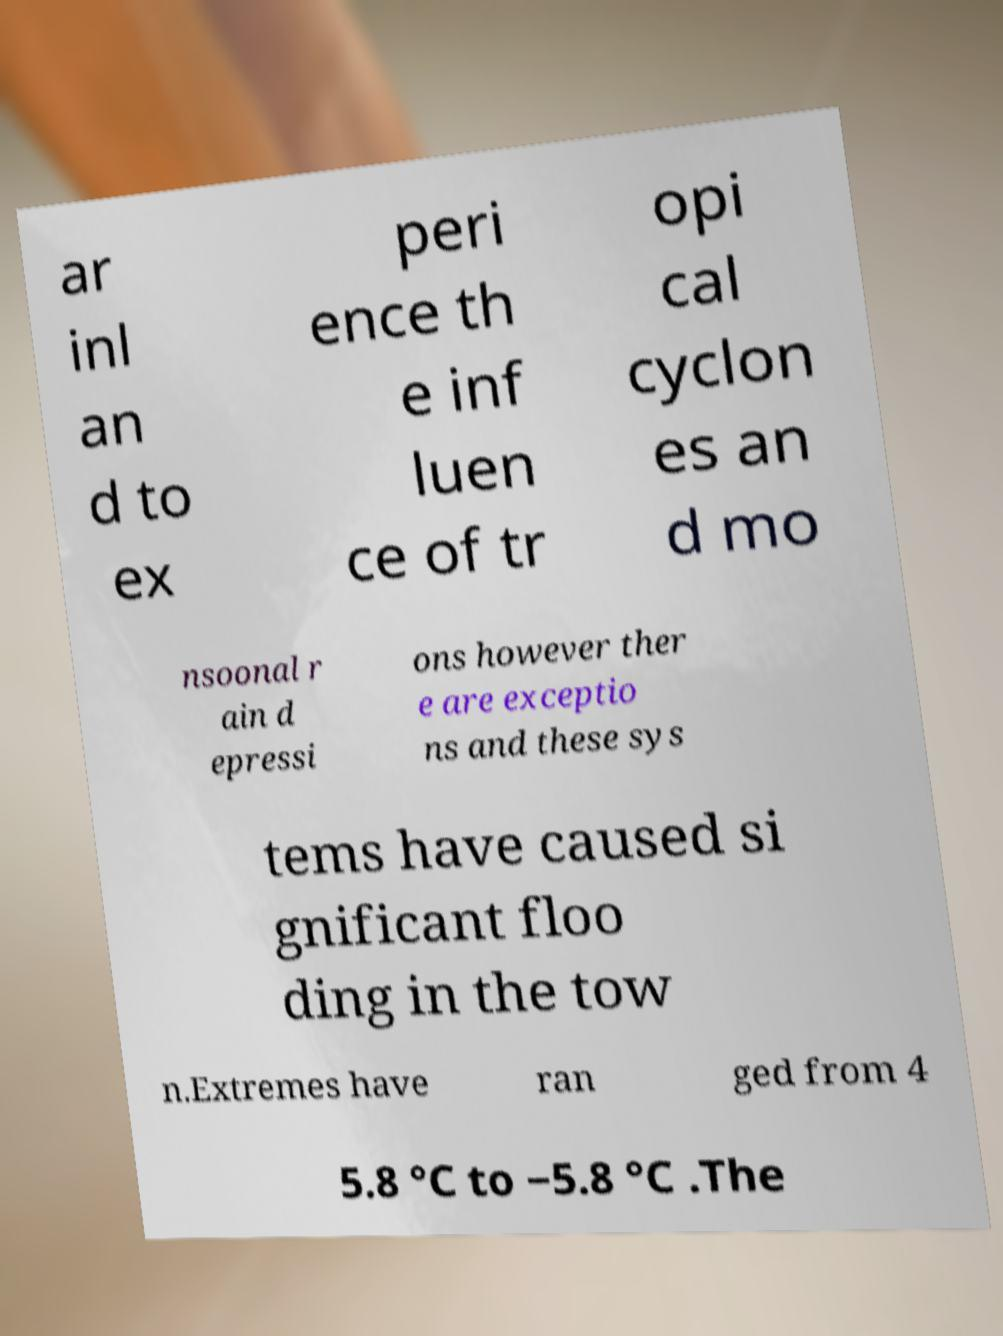For documentation purposes, I need the text within this image transcribed. Could you provide that? ar inl an d to ex peri ence th e inf luen ce of tr opi cal cyclon es an d mo nsoonal r ain d epressi ons however ther e are exceptio ns and these sys tems have caused si gnificant floo ding in the tow n.Extremes have ran ged from 4 5.8 °C to −5.8 °C .The 